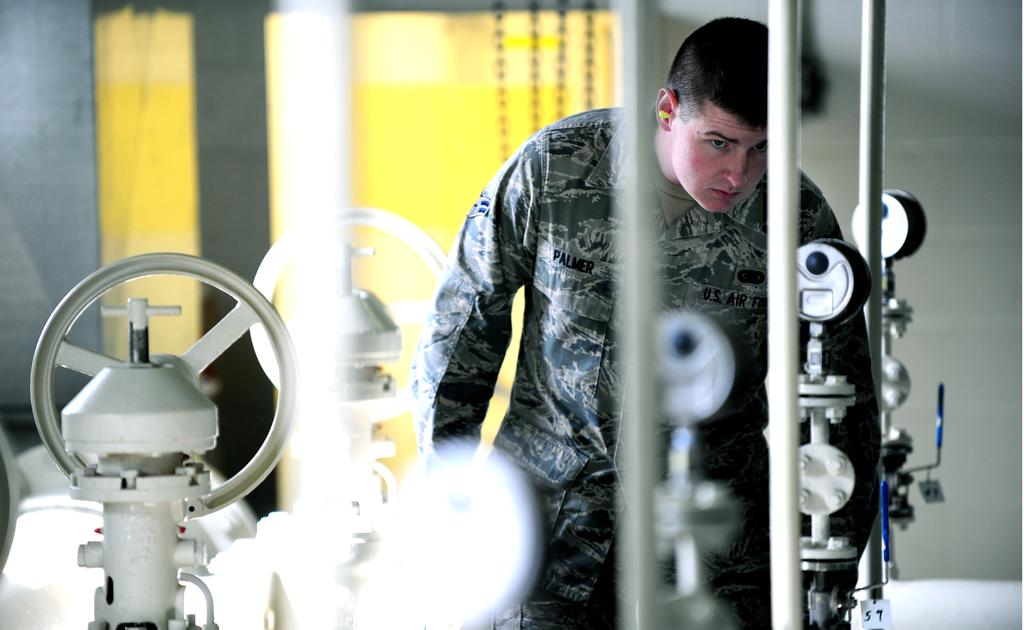What is the main subject of the image? There is a person in the image. What else can be seen in the image besides the person? There are machines in the image. What is visible in the background of the image? There is a wall in the background of the image. Can you describe the yellow object on the wall? There is a yellow colored object on the wall. What type of bells can be heard ringing in the image? There are no bells present in the image, and therefore no sound can be heard. 